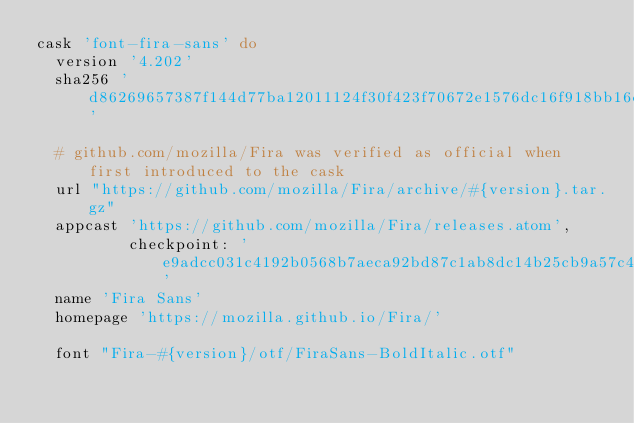<code> <loc_0><loc_0><loc_500><loc_500><_Ruby_>cask 'font-fira-sans' do
  version '4.202'
  sha256 'd86269657387f144d77ba12011124f30f423f70672e1576dc16f918bb16ddfe4'

  # github.com/mozilla/Fira was verified as official when first introduced to the cask
  url "https://github.com/mozilla/Fira/archive/#{version}.tar.gz"
  appcast 'https://github.com/mozilla/Fira/releases.atom',
          checkpoint: 'e9adcc031c4192b0568b7aeca92bd87c1ab8dc14b25cb9a57c43e89dc95efaa5'
  name 'Fira Sans'
  homepage 'https://mozilla.github.io/Fira/'

  font "Fira-#{version}/otf/FiraSans-BoldItalic.otf"</code> 